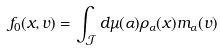<formula> <loc_0><loc_0><loc_500><loc_500>f _ { 0 } ( x , v ) = \int _ { \mathcal { J } } d \mu ( \alpha ) \rho _ { \alpha } ( x ) m _ { \alpha } ( v )</formula> 